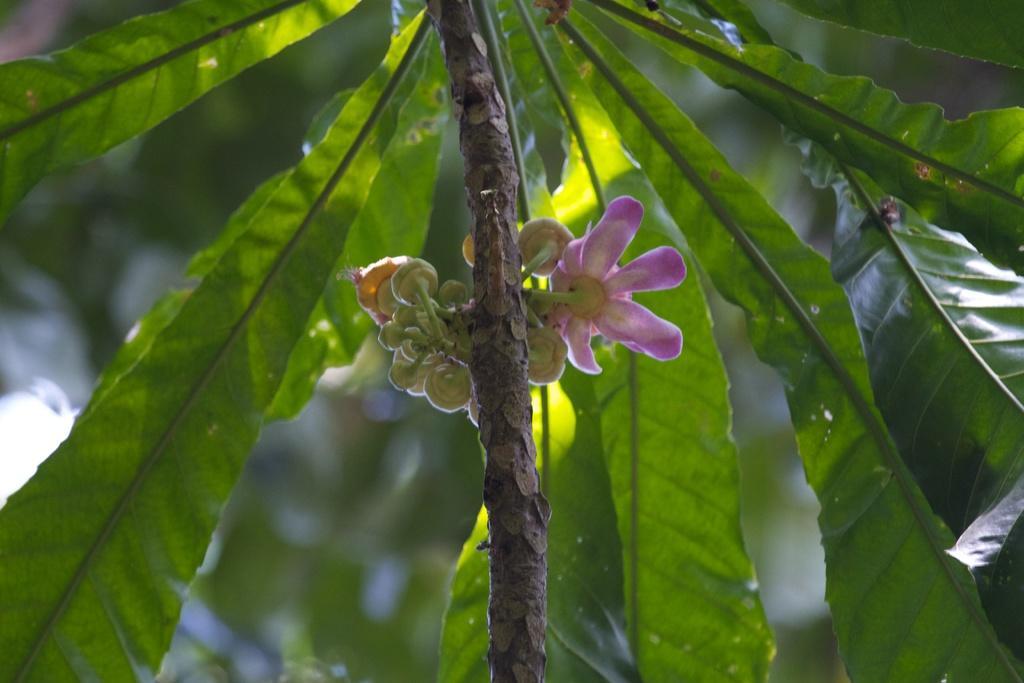Can you describe this image briefly? In this image we can see few flowers and buds to a plant. The background of the image is blurred. 